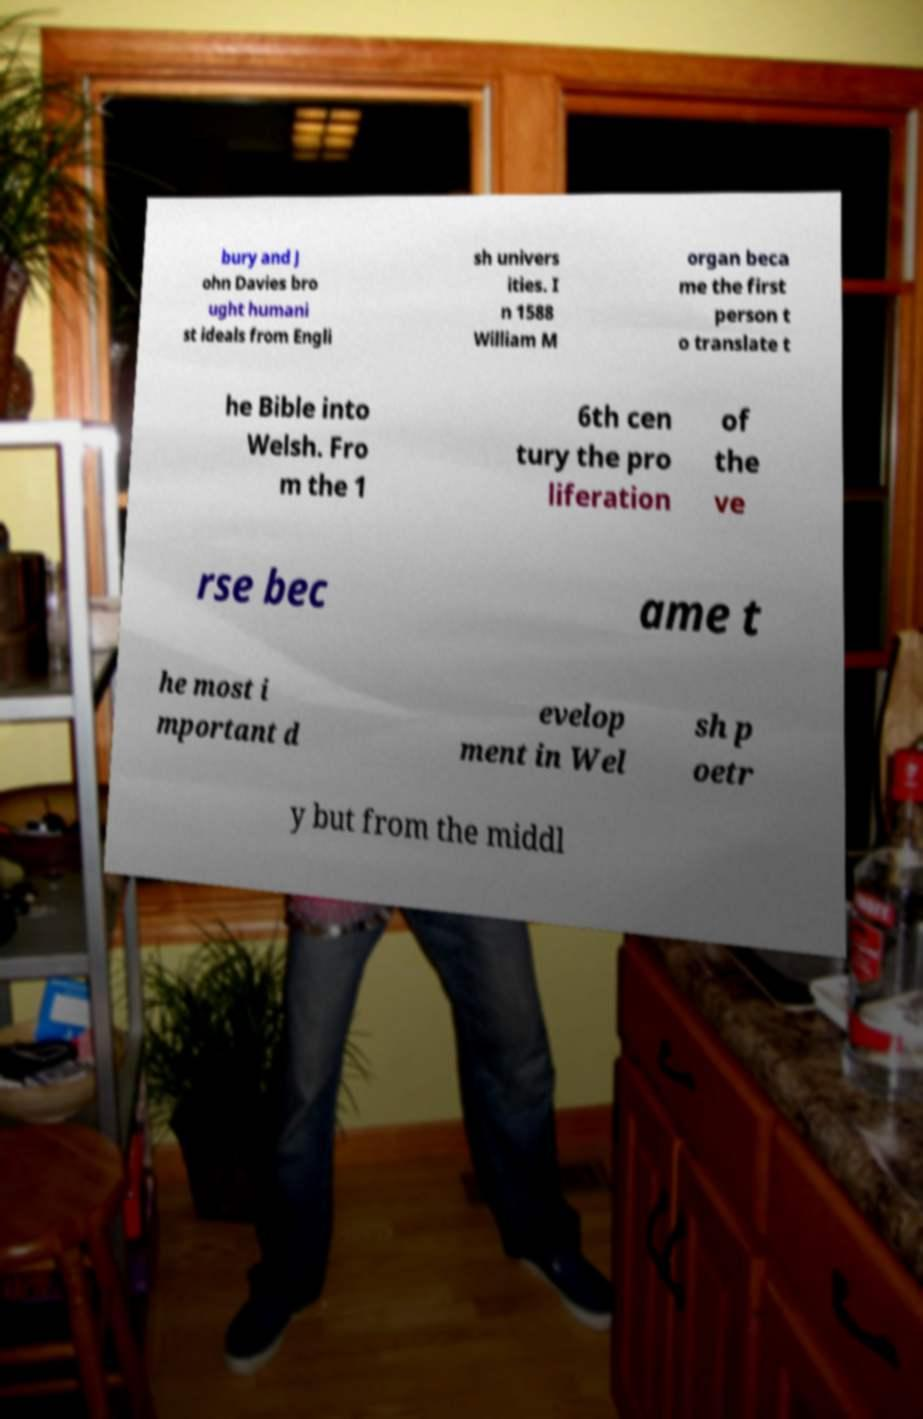Please read and relay the text visible in this image. What does it say? bury and J ohn Davies bro ught humani st ideals from Engli sh univers ities. I n 1588 William M organ beca me the first person t o translate t he Bible into Welsh. Fro m the 1 6th cen tury the pro liferation of the ve rse bec ame t he most i mportant d evelop ment in Wel sh p oetr y but from the middl 